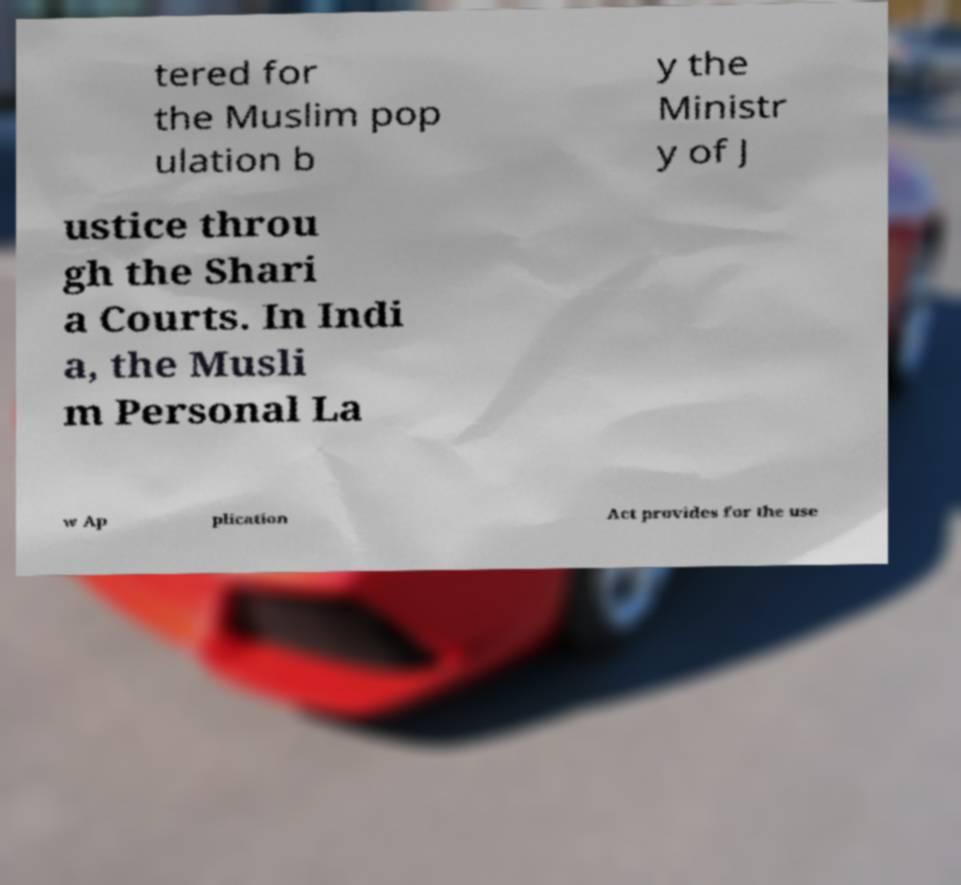Can you accurately transcribe the text from the provided image for me? tered for the Muslim pop ulation b y the Ministr y of J ustice throu gh the Shari a Courts. In Indi a, the Musli m Personal La w Ap plication Act provides for the use 